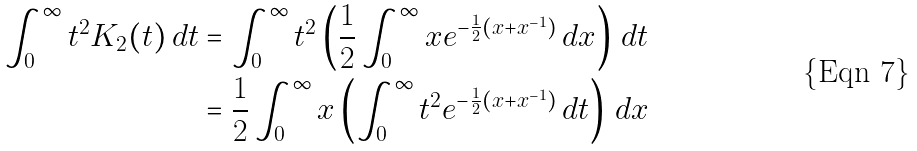<formula> <loc_0><loc_0><loc_500><loc_500>\int _ { 0 } ^ { \infty } t ^ { 2 } K _ { 2 } ( t ) \, d t & = \int _ { 0 } ^ { \infty } t ^ { 2 } \left ( \frac { 1 } { 2 } \int _ { 0 } ^ { \infty } x e ^ { - \frac { 1 } { 2 } ( x + x ^ { - 1 } ) } \, d x \right ) \, d t \\ & = \frac { 1 } { 2 } \int _ { 0 } ^ { \infty } x \left ( \int _ { 0 } ^ { \infty } t ^ { 2 } e ^ { - \frac { 1 } { 2 } ( x + x ^ { - 1 } ) } \, d t \right ) \, d x</formula> 